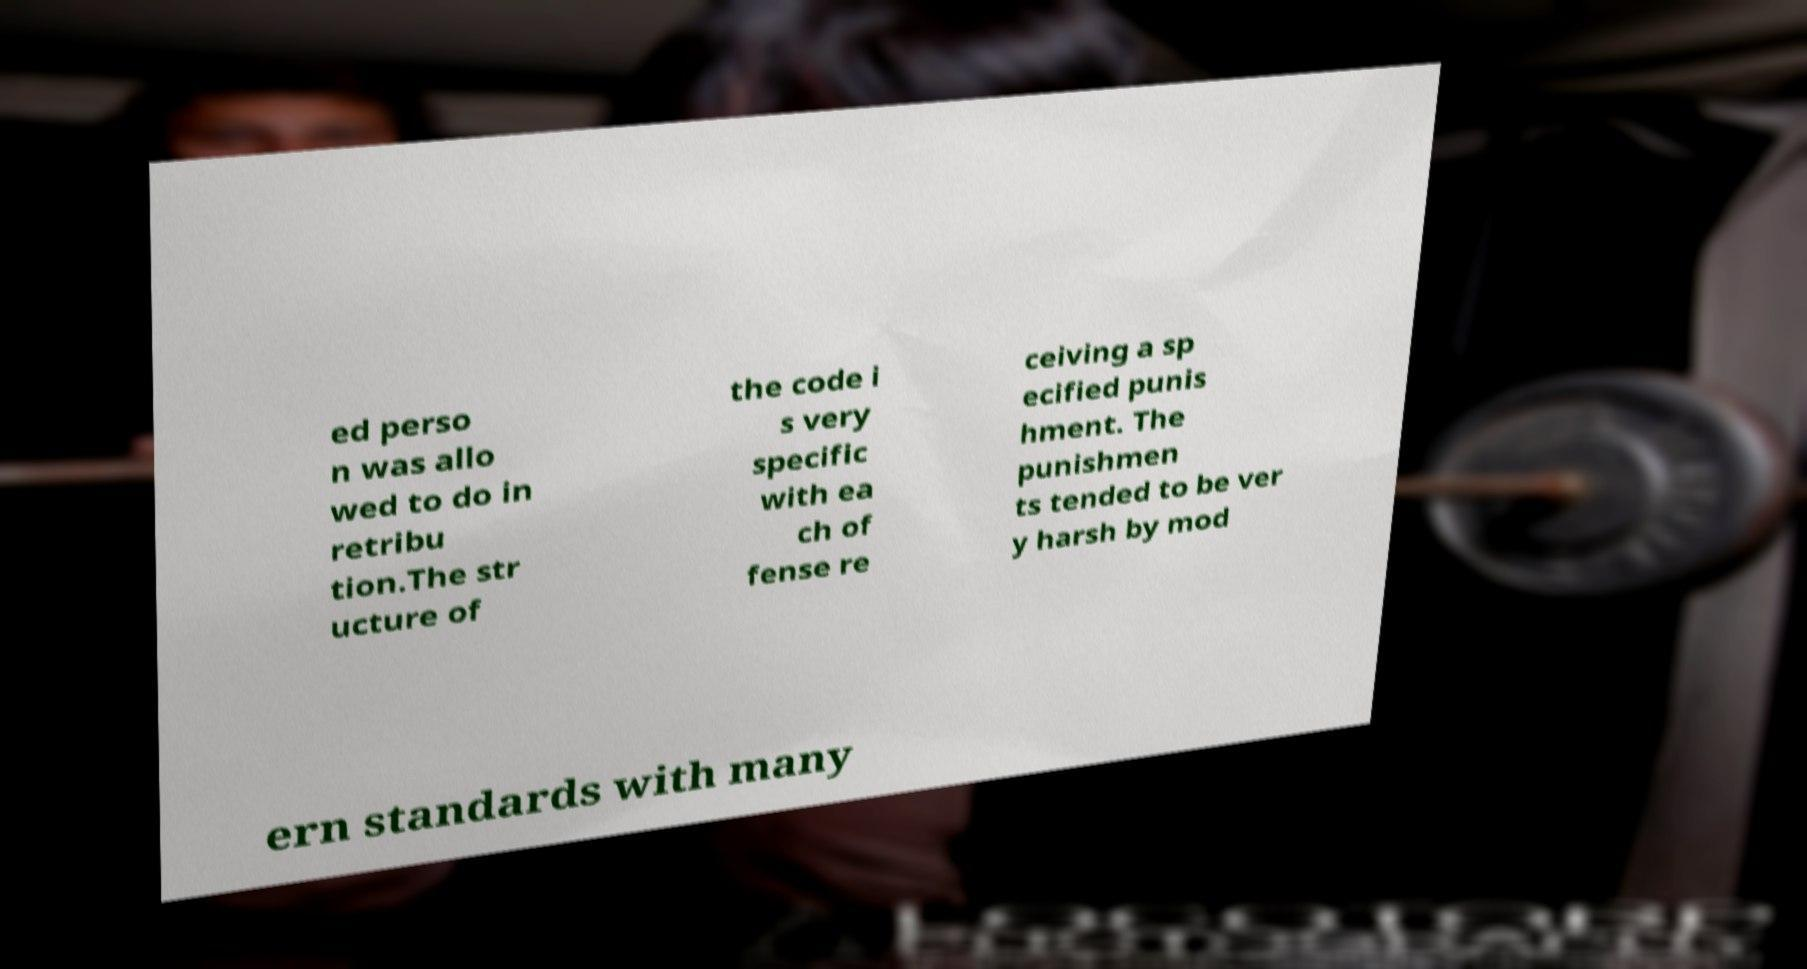Please read and relay the text visible in this image. What does it say? ed perso n was allo wed to do in retribu tion.The str ucture of the code i s very specific with ea ch of fense re ceiving a sp ecified punis hment. The punishmen ts tended to be ver y harsh by mod ern standards with many 